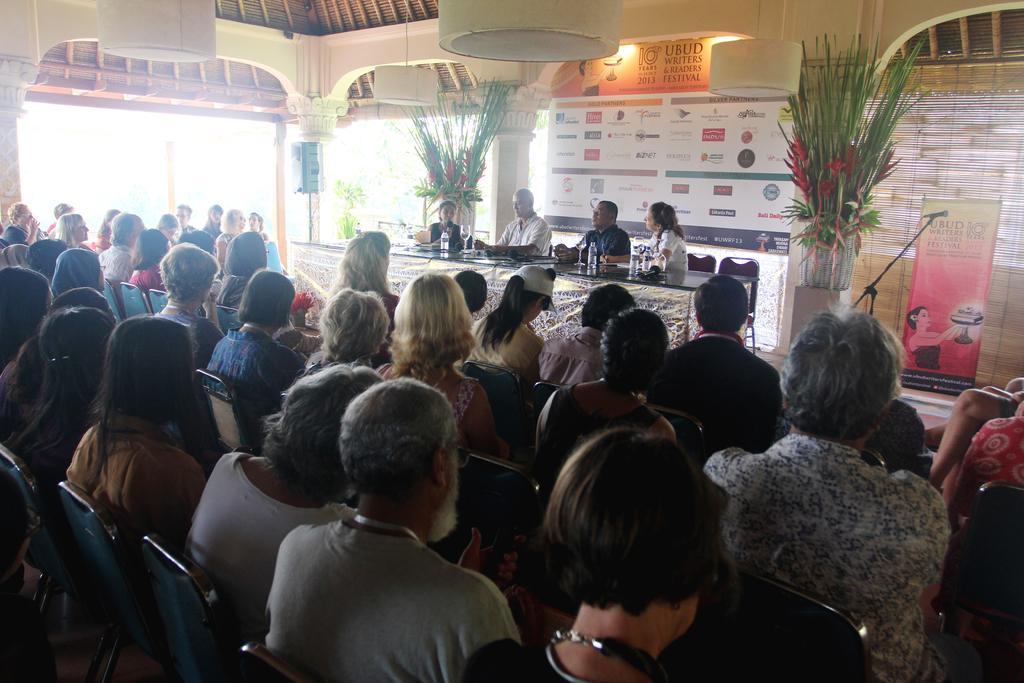In one or two sentences, can you explain what this image depicts? In this image there are people sitting on chairs in the foreground. There is a poster and a window blind in the right corner. There are chairs, people and table with glasses, potted plants, a poster in the background. And there is roof at the top. 